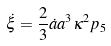Convert formula to latex. <formula><loc_0><loc_0><loc_500><loc_500>\dot { \xi } = \frac { 2 } { 3 } \dot { a } a ^ { 3 } \kappa ^ { 2 } p _ { 5 }</formula> 